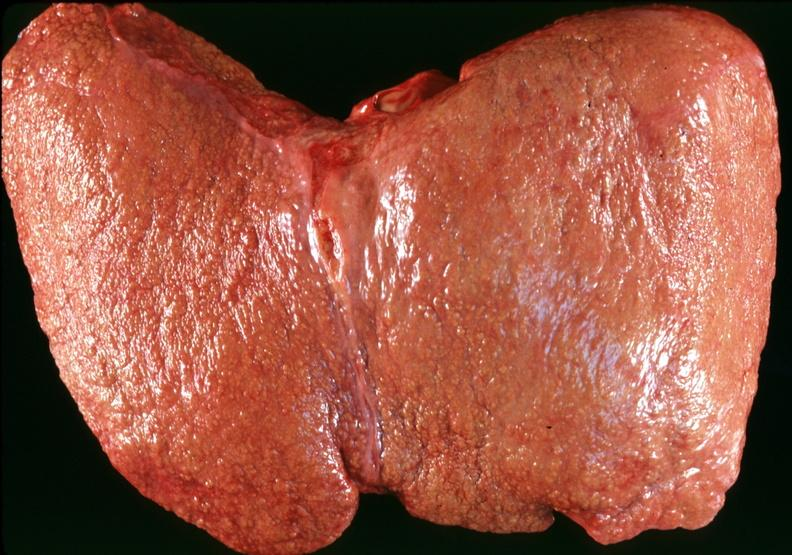does this image show cirrhosis?
Answer the question using a single word or phrase. Yes 